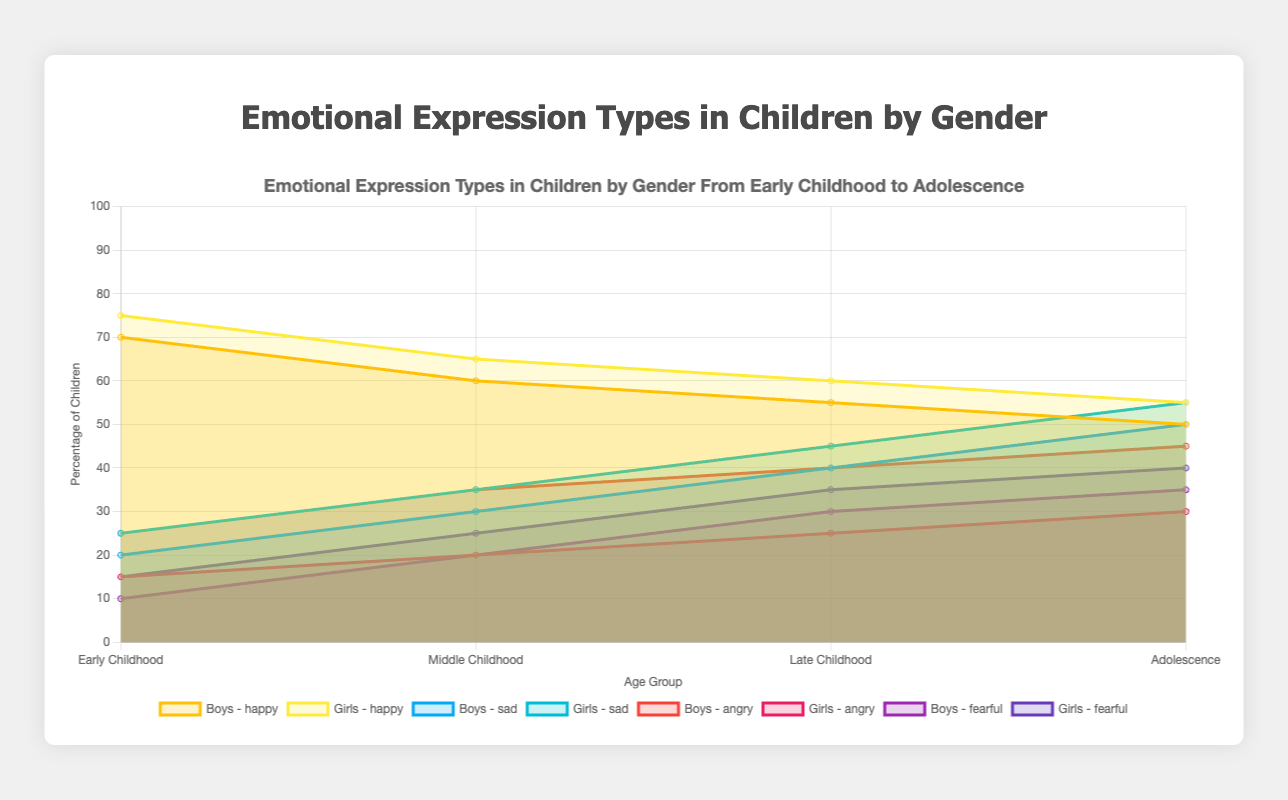What are the age groups represented in the figure? The x-axis of the figure shows the different age groups. By reading the labels, we can identify the groups represented.
Answer: Early Childhood, Middle Childhood, Late Childhood, Adolescence Which gender shows a higher percentage of "happy" emotion in Early Childhood? By referring to the data points for "happy" emotion for both boys and girls in the "Early Childhood" age group, we compare the values. Boys are at 70% and girls at 75%.
Answer: Girls What is the difference in the "sad" emotion percentage between Boys and Girls in Late Childhood? Referring to the “sad” emotion percentages for both genders in Late Childhood: Boys have 40%, and girls have 45%. The difference can be calculated by subtracting 40 from 45 (45-40).
Answer: 5% For "angry" emotion, which gender shows a higher cumulative percentage across all age groups? Summing the "angry" percentages for Boys (25+35+40+45) gives 145%, and for Girls (15+20+25+30) gives 90%. Boys have a higher cumulative percentage.
Answer: Boys Which emotion shows the smallest increase for Boys from Early Childhood to Adolescence? Checking all emotions for Boys, the increases are: 
- Happy: 70% to 50% (-20%)
- Sad: 20% to 50% (+30%)
- Angry: 25% to 45% (+20%)
- Fearful: 10% to 35% (+25%)
"Happiness" shows a decrease, not an increase; next smallest increase is "Angry" with 20%.
Answer: Angry Between Middle Childhood and Late Childhood, which emotion for Girls shows an increase? Comparing the percentages for each emotion from Middle Childhood to Late Childhood for girls: "happy" (65 to 60), "sad" (35 to 45), “angry” (20 to 25), and “fearful” (25 to 35). "Sad," "Angry," and "Fearful" all show increases.
Answer: Sad, Angry, Fearful Which emotion shows the most significant gender difference in Adolescence? Looking at each emotion's percentages for Boys and Girls in Adolescence: 
- Happy (Boys: 50%, Girls: 55%) = 5%
- Sad (Boys: 50%, Girls: 55%) = 5%
- Angry (Boys: 45%, Girls: 30%) = 15%
- Fearful (Boys: 35%, Girls: 40%) = 5%
"Angry" shows the most significant gender difference at 15%.
Answer: Angry 